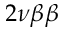<formula> <loc_0><loc_0><loc_500><loc_500>2 \nu \beta \beta</formula> 